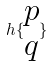Convert formula to latex. <formula><loc_0><loc_0><loc_500><loc_500>h \{ \begin{matrix} p \\ q \end{matrix} \}</formula> 